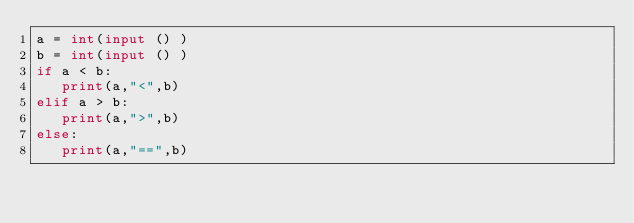<code> <loc_0><loc_0><loc_500><loc_500><_Python_>a = int(input () )
b = int(input () )
if a < b:
   print(a,"<",b)
elif a > b:
   print(a,">",b)
else:
   print(a,"==",b)</code> 